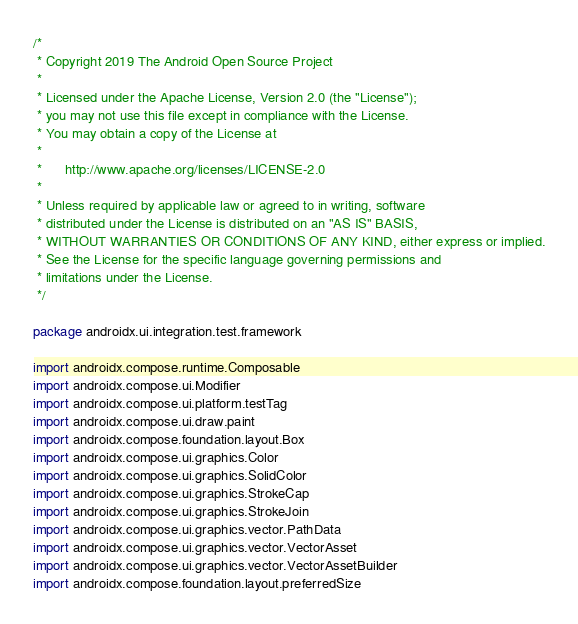<code> <loc_0><loc_0><loc_500><loc_500><_Kotlin_>/*
 * Copyright 2019 The Android Open Source Project
 *
 * Licensed under the Apache License, Version 2.0 (the "License");
 * you may not use this file except in compliance with the License.
 * You may obtain a copy of the License at
 *
 *      http://www.apache.org/licenses/LICENSE-2.0
 *
 * Unless required by applicable law or agreed to in writing, software
 * distributed under the License is distributed on an "AS IS" BASIS,
 * WITHOUT WARRANTIES OR CONDITIONS OF ANY KIND, either express or implied.
 * See the License for the specific language governing permissions and
 * limitations under the License.
 */

package androidx.ui.integration.test.framework

import androidx.compose.runtime.Composable
import androidx.compose.ui.Modifier
import androidx.compose.ui.platform.testTag
import androidx.compose.ui.draw.paint
import androidx.compose.foundation.layout.Box
import androidx.compose.ui.graphics.Color
import androidx.compose.ui.graphics.SolidColor
import androidx.compose.ui.graphics.StrokeCap
import androidx.compose.ui.graphics.StrokeJoin
import androidx.compose.ui.graphics.vector.PathData
import androidx.compose.ui.graphics.vector.VectorAsset
import androidx.compose.ui.graphics.vector.VectorAssetBuilder
import androidx.compose.foundation.layout.preferredSize</code> 